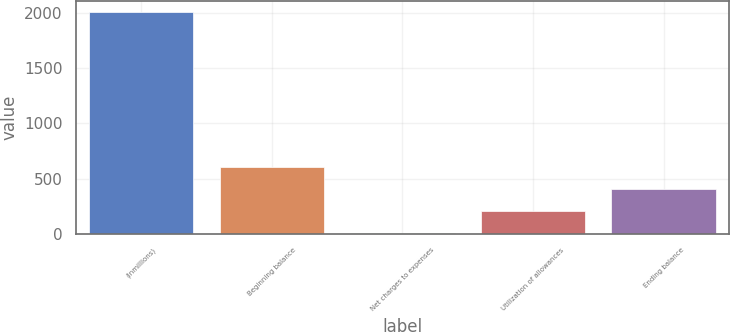Convert chart to OTSL. <chart><loc_0><loc_0><loc_500><loc_500><bar_chart><fcel>(inmillions)<fcel>Beginning balance<fcel>Net charges to expenses<fcel>Utilization of allowances<fcel>Ending balance<nl><fcel>2013<fcel>607.4<fcel>5<fcel>205.8<fcel>406.6<nl></chart> 